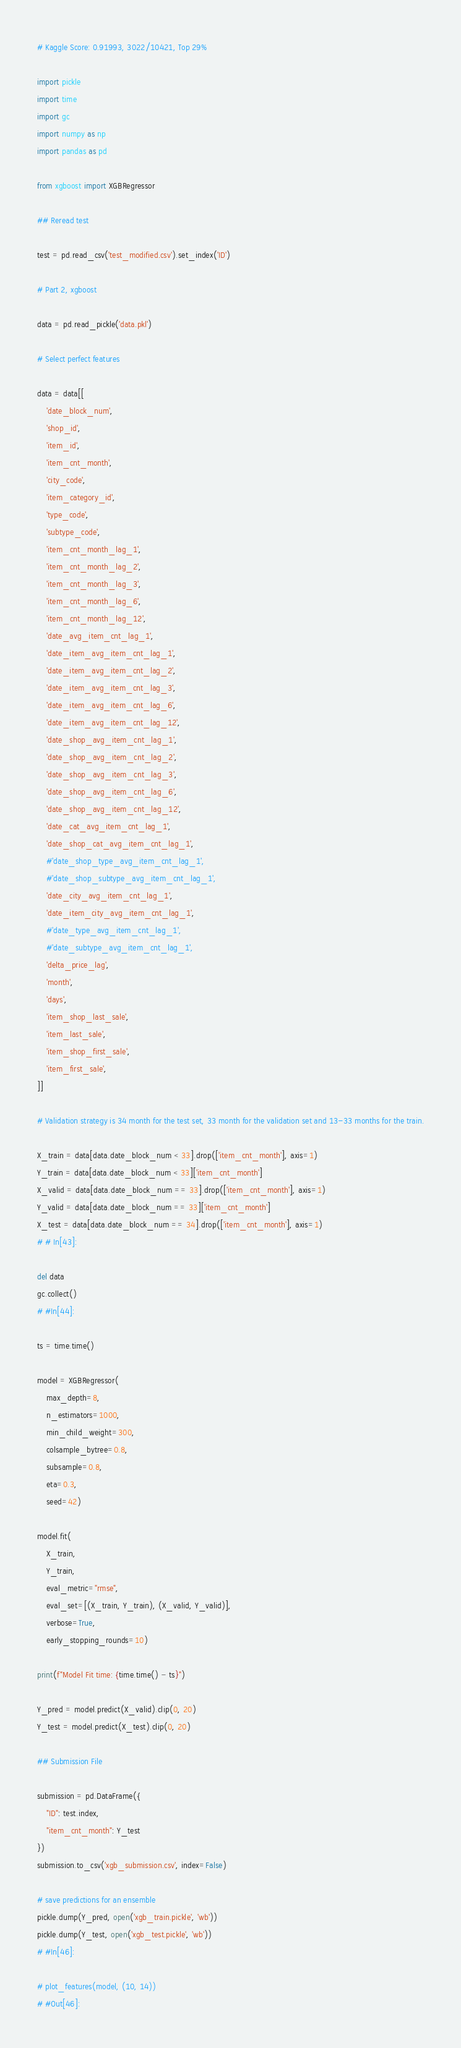Convert code to text. <code><loc_0><loc_0><loc_500><loc_500><_Python_># Kaggle Score: 0.91993, 3022/10421, Top 29%

import pickle
import time
import gc
import numpy as np
import pandas as pd

from xgboost import XGBRegressor

## Reread test

test = pd.read_csv('test_modified.csv').set_index('ID')

# Part 2, xgboost

data = pd.read_pickle('data.pkl')

# Select perfect features

data = data[[
    'date_block_num',
    'shop_id',
    'item_id',
    'item_cnt_month',
    'city_code',
    'item_category_id',
    'type_code',
    'subtype_code',
    'item_cnt_month_lag_1',
    'item_cnt_month_lag_2',
    'item_cnt_month_lag_3',
    'item_cnt_month_lag_6',
    'item_cnt_month_lag_12',
    'date_avg_item_cnt_lag_1',
    'date_item_avg_item_cnt_lag_1',
    'date_item_avg_item_cnt_lag_2',
    'date_item_avg_item_cnt_lag_3',
    'date_item_avg_item_cnt_lag_6',
    'date_item_avg_item_cnt_lag_12',
    'date_shop_avg_item_cnt_lag_1',
    'date_shop_avg_item_cnt_lag_2',
    'date_shop_avg_item_cnt_lag_3',
    'date_shop_avg_item_cnt_lag_6',
    'date_shop_avg_item_cnt_lag_12',
    'date_cat_avg_item_cnt_lag_1',
    'date_shop_cat_avg_item_cnt_lag_1',
    #'date_shop_type_avg_item_cnt_lag_1',
    #'date_shop_subtype_avg_item_cnt_lag_1',
    'date_city_avg_item_cnt_lag_1',
    'date_item_city_avg_item_cnt_lag_1',
    #'date_type_avg_item_cnt_lag_1',
    #'date_subtype_avg_item_cnt_lag_1',
    'delta_price_lag',
    'month',
    'days',
    'item_shop_last_sale',
    'item_last_sale',
    'item_shop_first_sale',
    'item_first_sale',
]]

# Validation strategy is 34 month for the test set, 33 month for the validation set and 13-33 months for the train.

X_train = data[data.date_block_num < 33].drop(['item_cnt_month'], axis=1)
Y_train = data[data.date_block_num < 33]['item_cnt_month']
X_valid = data[data.date_block_num == 33].drop(['item_cnt_month'], axis=1)
Y_valid = data[data.date_block_num == 33]['item_cnt_month']
X_test = data[data.date_block_num == 34].drop(['item_cnt_month'], axis=1)
# # In[43]:

del data
gc.collect()
# #In[44]:

ts = time.time()

model = XGBRegressor(
    max_depth=8,
    n_estimators=1000,
    min_child_weight=300,
    colsample_bytree=0.8,
    subsample=0.8,
    eta=0.3,
    seed=42)

model.fit(
    X_train,
    Y_train,
    eval_metric="rmse",
    eval_set=[(X_train, Y_train), (X_valid, Y_valid)],
    verbose=True,
    early_stopping_rounds=10)

print(f"Model Fit time: {time.time() - ts}")

Y_pred = model.predict(X_valid).clip(0, 20)
Y_test = model.predict(X_test).clip(0, 20)

## Submission File

submission = pd.DataFrame({
    "ID": test.index,
    "item_cnt_month": Y_test
})
submission.to_csv('xgb_submission.csv', index=False)

# save predictions for an ensemble
pickle.dump(Y_pred, open('xgb_train.pickle', 'wb'))
pickle.dump(Y_test, open('xgb_test.pickle', 'wb'))
# #In[46]:

# plot_features(model, (10, 14))
# #Out[46]:
</code> 